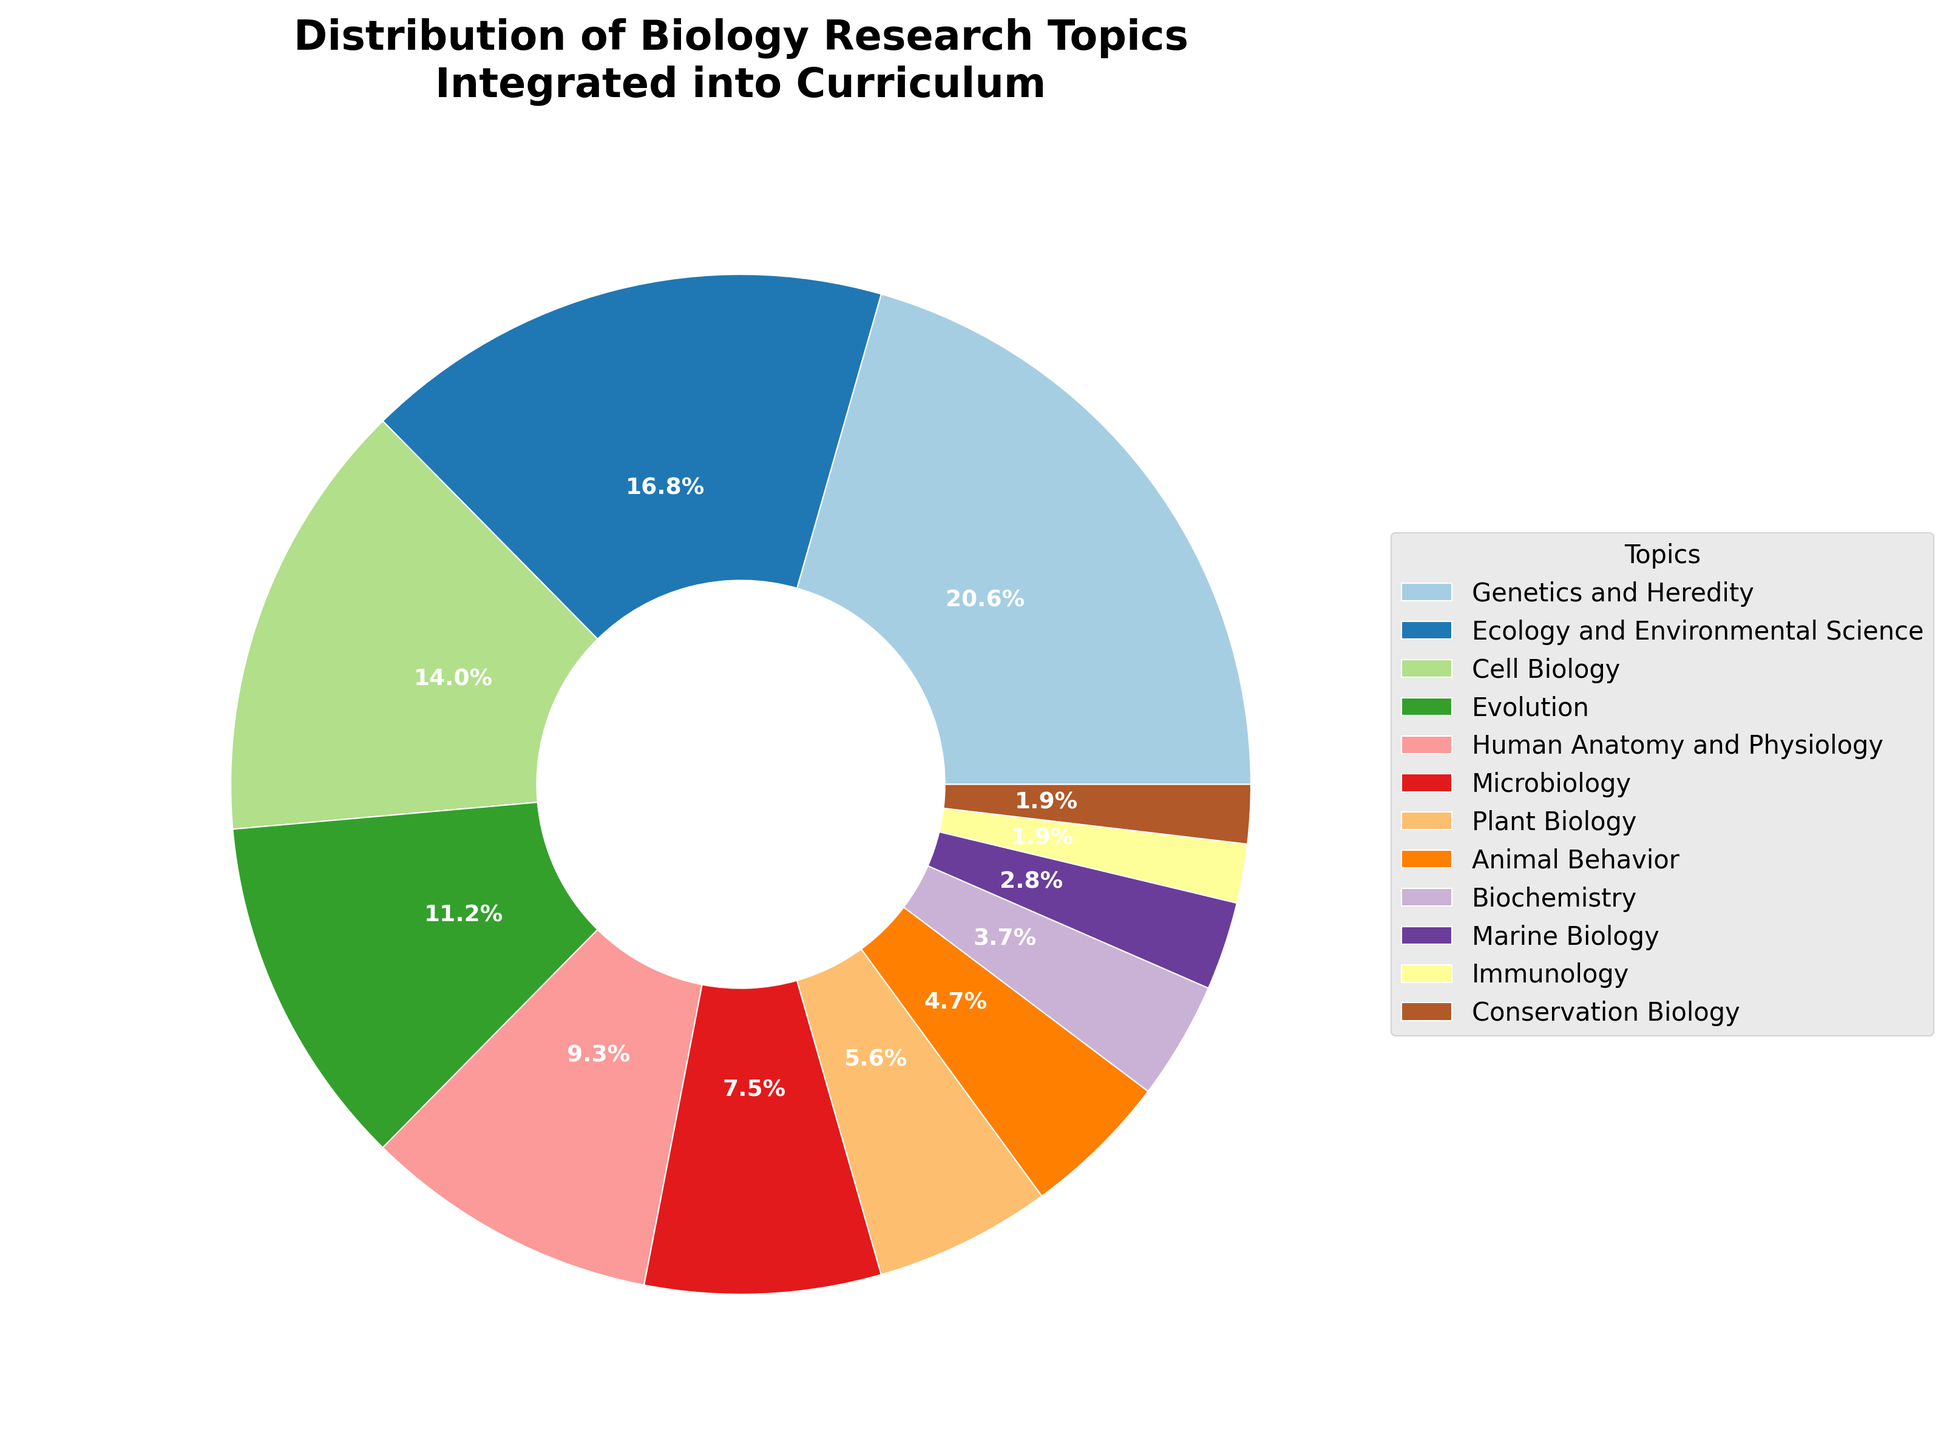What are the two most integrated research topics? The wedges of the pie chart show the distribution, and the largest two slices represent the most integrated topics. Genetics and Heredity at 22% and Ecology and Environmental Science at 18%.
Answer: Genetics and Heredity, Ecology and Environmental Science Which topic has a smaller percentage, Marine Biology or Biochemistry? We compare the wedges representing Marine Biology and Biochemistry. Marine Biology is 3% and Biochemistry is 4%, so Marine Biology is smaller.
Answer: Marine Biology What is the combined percentage of Evolution and Human Anatomy and Physiology? Find the wedges for Evolution and Human Anatomy and Physiology and add their percentages: 12% + 10%.
Answer: 22% Which three topics have the least integration? Look for the smallest wedges in the pie chart. Immunology and Conservation Biology are both at 2%, and Marine Biology is at 3%.
Answer: Immunology, Conservation Biology, Marine Biology How much larger is the percentage of Cell Biology compared to Plant Biology? Look at the wedges for Cell Biology and Plant Biology and subtract their percentages: 15% - 6%.
Answer: 9% What is the average percentage of the following topics: Microbiology, Plant Biology, and Animal Behavior? Add the percentages of Microbiology, Plant Biology, and Animal Behavior: 8% + 6% + 5% = 19%. Then divide by 3: 19% / 3.
Answer: Approximately 6.33% Which topic is the fourth most integrated in the curriculum? Find the fourth largest wedge. Evolution is 12%, making it the fourth most integrated topic.
Answer: Evolution If you combine the percentages of Genetics and Heredity, and Cell Biology, how much larger are they compared to Immunology, Conservation Biology, Marine Biology, and Biochemistry combined? Add the percentages of Genetics and Heredity, and Cell Biology: 22% + 15% = 37%. Then add the percentages of Immunology, Conservation Biology, Marine Biology, and Biochemistry: 2% + 2% + 3% + 4% = 11%. Subtract the two sums: 37% - 11%.
Answer: 26% Which topic is represented by the green wedge? Look closely at the chart legend to find which topic's color corresponds to green when comparing all the legend elements.
Answer: Answer depends on the figure's color palette and context (not able to definitively answer without viewing the actual figure) How does the combined percentage of topics related to living organisms (Animal Behavior, Human Anatomy and Physiology, Microbiology, Cell Biology) compare to non-living organisms (Ecology and Environmental Science, Conservation Biology)? Sum up Animal Behavior, Human Anatomy and Physiology, Microbiology, and Cell Biology: 5% + 10% + 8% + 15% = 38%. For non-living organisms, sum Ecology and Environmental Science and Conservation Biology: 18% + 2% = 20%. Compare: 38% vs. 20%.
Answer: 38% vs. 20% Which topic is the second least integrated into the curriculum? Look for the second smallest wedge after identifying the smallest. Conservation Biology is 2%, the same as Immunology, so they are tied for the second least integrated.
Answer: Conservation Biology 